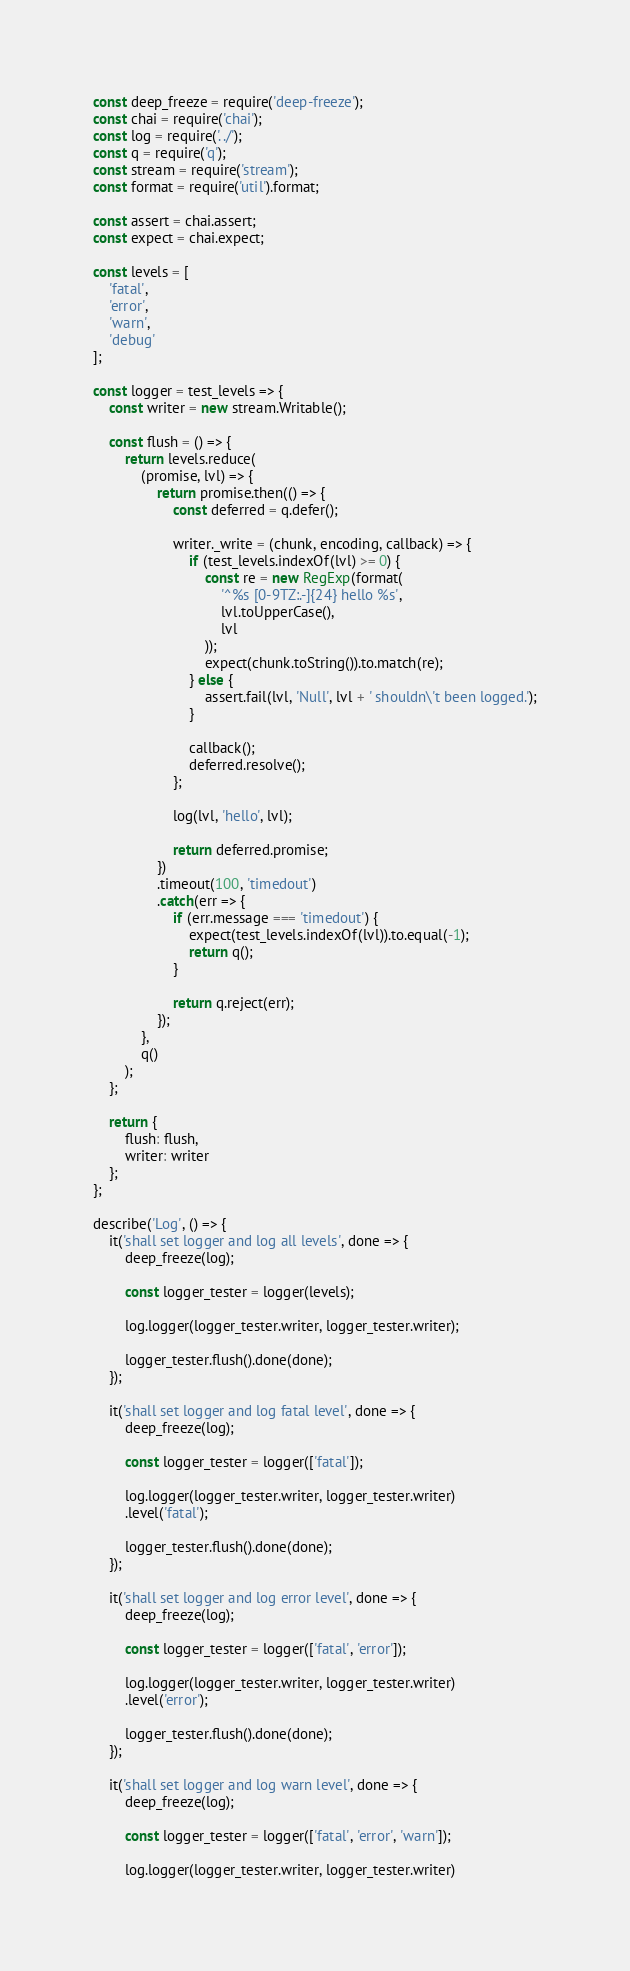<code> <loc_0><loc_0><loc_500><loc_500><_JavaScript_>const deep_freeze = require('deep-freeze');
const chai = require('chai');
const log = require('../');
const q = require('q');
const stream = require('stream');
const format = require('util').format;

const assert = chai.assert;
const expect = chai.expect;

const levels = [
    'fatal',
    'error',
    'warn',
    'debug'
];

const logger = test_levels => {
    const writer = new stream.Writable();

    const flush = () => {
        return levels.reduce(
            (promise, lvl) => {
                return promise.then(() => {
                    const deferred = q.defer();

                    writer._write = (chunk, encoding, callback) => {
                        if (test_levels.indexOf(lvl) >= 0) {
                            const re = new RegExp(format(
                                '^%s [0-9TZ:.-]{24} hello %s',
                                lvl.toUpperCase(),
                                lvl
                            ));
                            expect(chunk.toString()).to.match(re);
                        } else {
                            assert.fail(lvl, 'Null', lvl + ' shouldn\'t been logged.');
                        }

                        callback();
                        deferred.resolve();
                    };

                    log(lvl, 'hello', lvl);

                    return deferred.promise;
                })
                .timeout(100, 'timedout')
                .catch(err => {
                    if (err.message === 'timedout') {
                        expect(test_levels.indexOf(lvl)).to.equal(-1);
                        return q();
                    }

                    return q.reject(err);
                });
            },
            q()
        );
    };

    return {
        flush: flush,
        writer: writer
    };
};

describe('Log', () => {
    it('shall set logger and log all levels', done => {
        deep_freeze(log);

        const logger_tester = logger(levels);

        log.logger(logger_tester.writer, logger_tester.writer);

        logger_tester.flush().done(done);
    });

    it('shall set logger and log fatal level', done => {
        deep_freeze(log);

        const logger_tester = logger(['fatal']);

        log.logger(logger_tester.writer, logger_tester.writer)
        .level('fatal');

        logger_tester.flush().done(done);
    });

    it('shall set logger and log error level', done => {
        deep_freeze(log);

        const logger_tester = logger(['fatal', 'error']);

        log.logger(logger_tester.writer, logger_tester.writer)
        .level('error');

        logger_tester.flush().done(done);
    });

    it('shall set logger and log warn level', done => {
        deep_freeze(log);

        const logger_tester = logger(['fatal', 'error', 'warn']);

        log.logger(logger_tester.writer, logger_tester.writer)</code> 